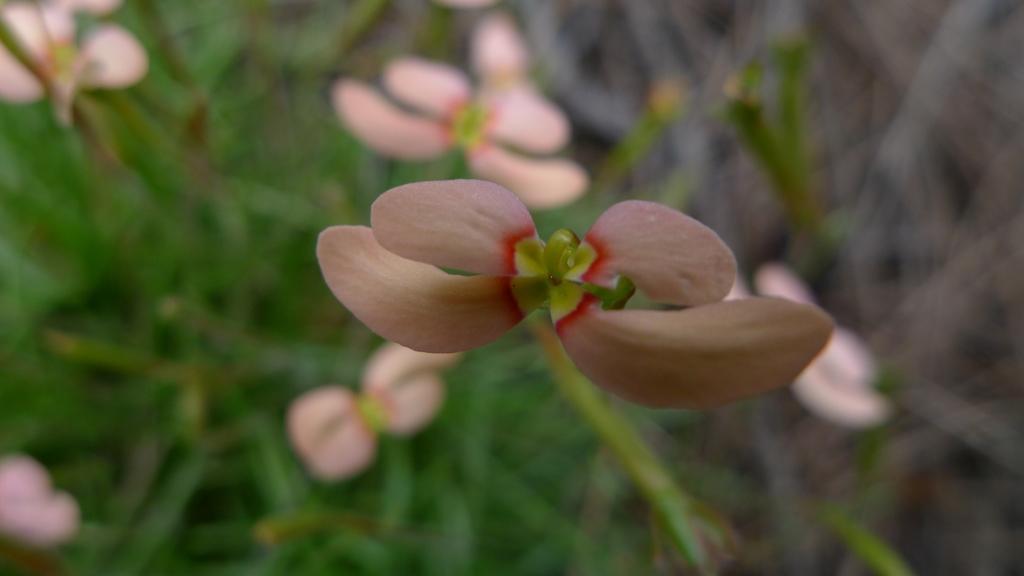Describe this image in one or two sentences. There is a flower. In the background it is looking blur and there are flowers and leaves. 